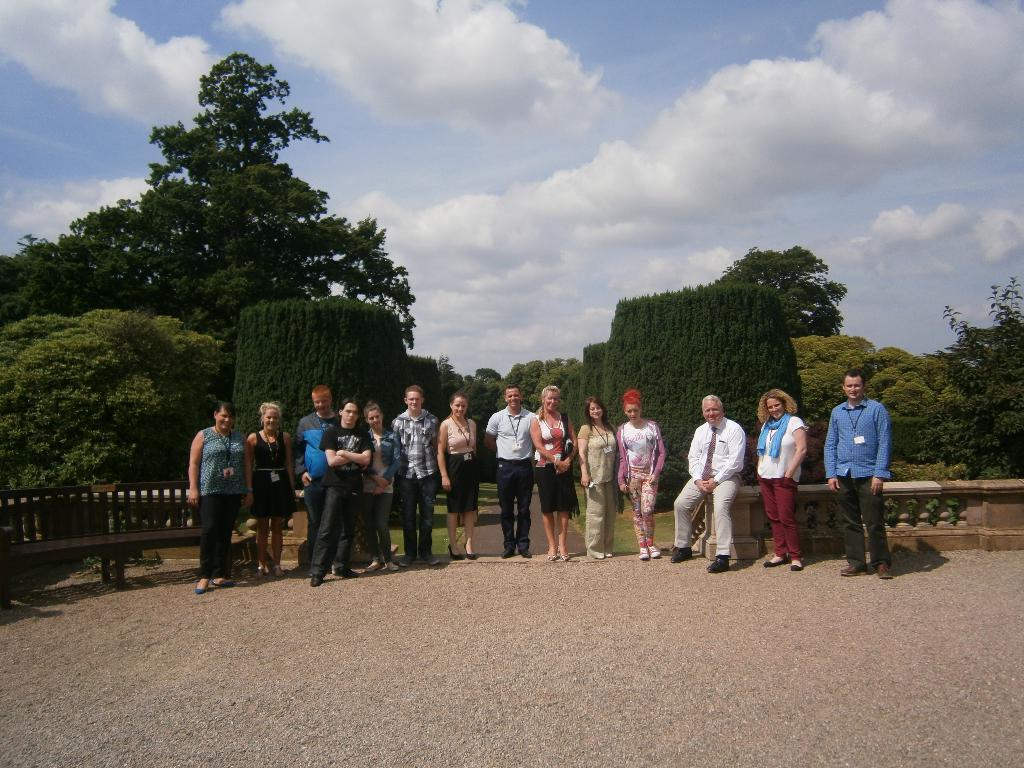Could you give a brief overview of what you see in this image? In the center of the image we can see one person is sitting and a few people are standing and they are in different costumes. In the background, we can see the sky, clouds, trees and fence. 